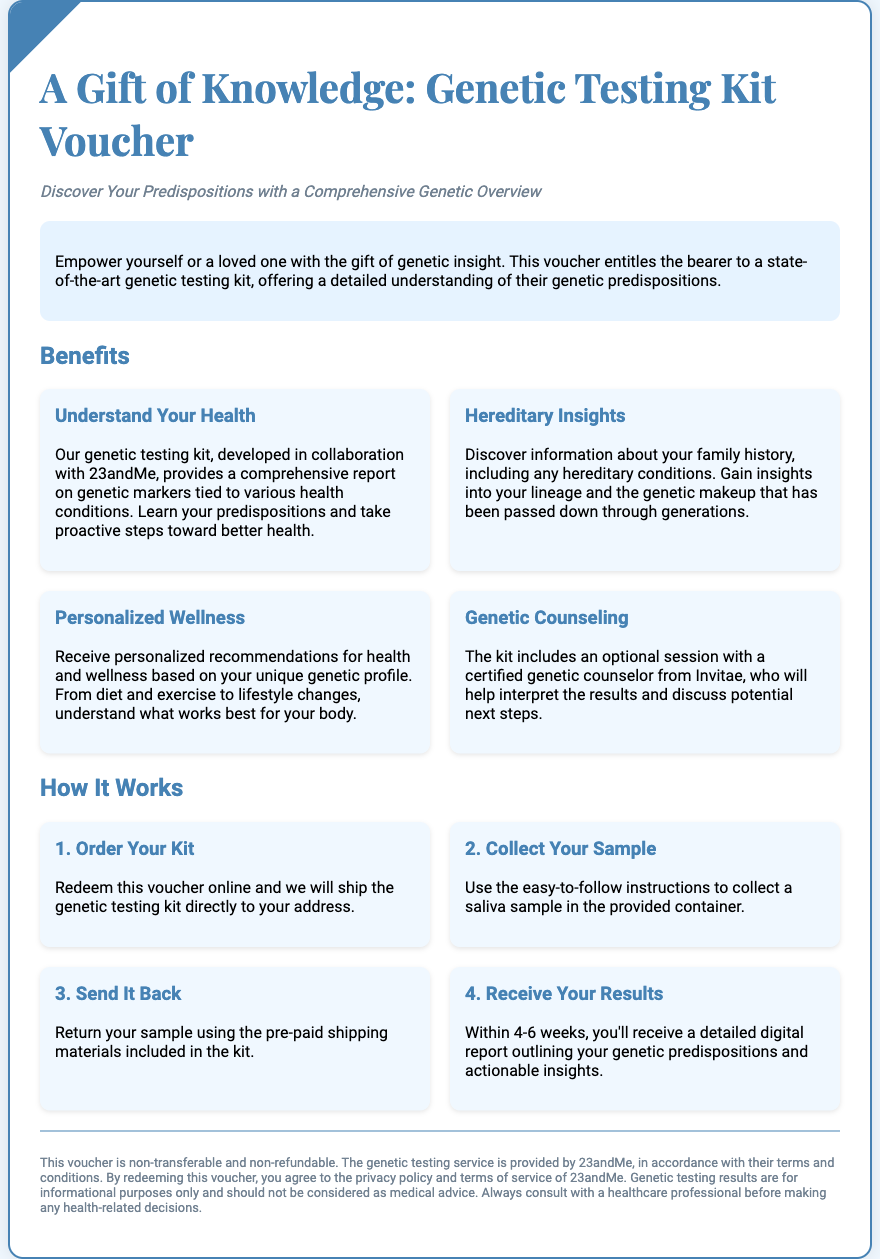What is the title of the voucher? The title of the voucher is presented prominently at the top of the document.
Answer: A Gift of Knowledge: Genetic Testing Kit Voucher Who developed the genetic testing kit? The document specifies that the genetic testing kit is developed in collaboration with a well-known company.
Answer: 23andMe What is included with the testing kit for additional support? The document mentions an additional service provided alongside the genetic testing kit.
Answer: Genetic counseling How long does it take to receive the results? The document outlines the expected timeframe for receiving test results.
Answer: 4-6 weeks What type of sample is required for the genetic test? The document states the kind of sample needed in the collection step.
Answer: Saliva What is the key benefit related to personal health? The document describes a specific advantage regarding individual health management.
Answer: Understand Your Health What is the disclaimer about the voucher regarding transfers? The document includes a policy statement concerning the nature of the voucher.
Answer: Non-transferable What information can be discovered through hereditary insights? The document elaborates on what individuals can learn about their family history.
Answer: Family history of hereditary conditions 